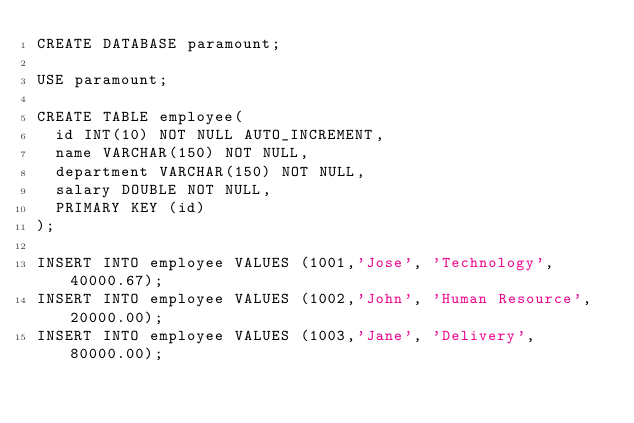<code> <loc_0><loc_0><loc_500><loc_500><_SQL_>CREATE DATABASE paramount;

USE paramount;

CREATE TABLE employee(
	id INT(10) NOT NULL AUTO_INCREMENT,
	name VARCHAR(150) NOT NULL,
	department VARCHAR(150) NOT NULL,
	salary DOUBLE NOT NULL,
	PRIMARY KEY (id)
);

INSERT INTO employee VALUES (1001,'Jose', 'Technology', 40000.67);
INSERT INTO employee VALUES (1002,'John', 'Human Resource', 20000.00);
INSERT INTO employee VALUES (1003,'Jane', 'Delivery', 80000.00);</code> 